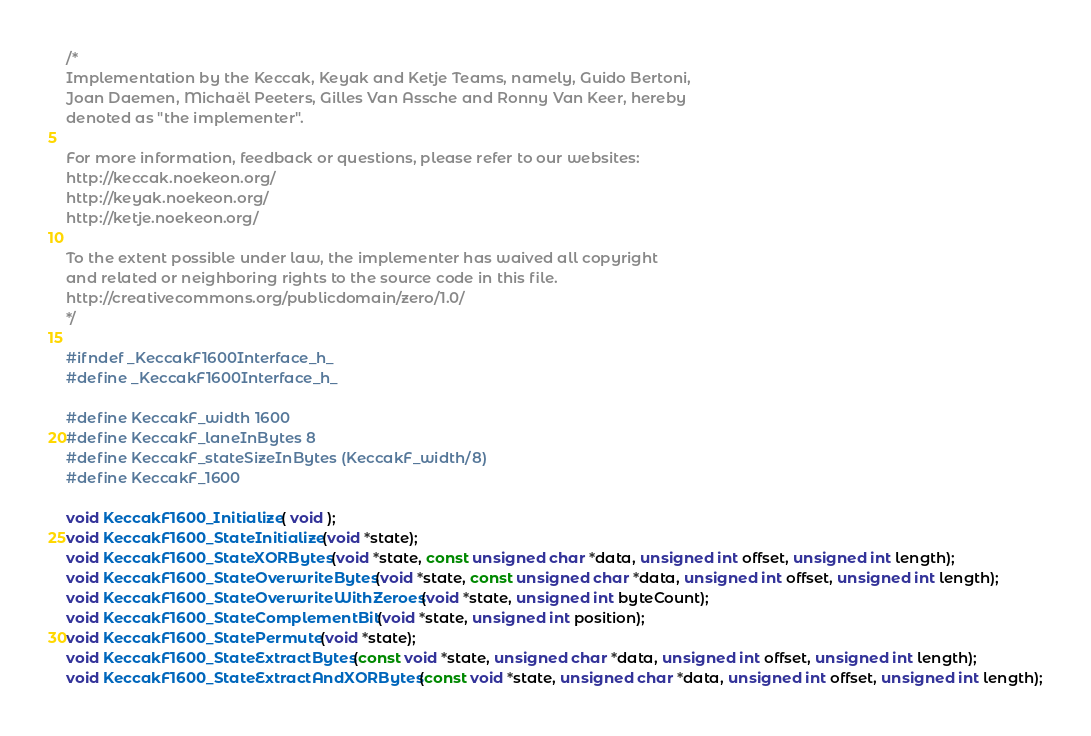Convert code to text. <code><loc_0><loc_0><loc_500><loc_500><_C_>/*
Implementation by the Keccak, Keyak and Ketje Teams, namely, Guido Bertoni,
Joan Daemen, Michaël Peeters, Gilles Van Assche and Ronny Van Keer, hereby
denoted as "the implementer".

For more information, feedback or questions, please refer to our websites:
http://keccak.noekeon.org/
http://keyak.noekeon.org/
http://ketje.noekeon.org/

To the extent possible under law, the implementer has waived all copyright
and related or neighboring rights to the source code in this file.
http://creativecommons.org/publicdomain/zero/1.0/
*/

#ifndef _KeccakF1600Interface_h_
#define _KeccakF1600Interface_h_

#define KeccakF_width 1600
#define KeccakF_laneInBytes 8
#define KeccakF_stateSizeInBytes (KeccakF_width/8)
#define KeccakF_1600

void KeccakF1600_Initialize( void );
void KeccakF1600_StateInitialize(void *state);
void KeccakF1600_StateXORBytes(void *state, const unsigned char *data, unsigned int offset, unsigned int length);
void KeccakF1600_StateOverwriteBytes(void *state, const unsigned char *data, unsigned int offset, unsigned int length);
void KeccakF1600_StateOverwriteWithZeroes(void *state, unsigned int byteCount);
void KeccakF1600_StateComplementBit(void *state, unsigned int position);
void KeccakF1600_StatePermute(void *state);
void KeccakF1600_StateExtractBytes(const void *state, unsigned char *data, unsigned int offset, unsigned int length);
void KeccakF1600_StateExtractAndXORBytes(const void *state, unsigned char *data, unsigned int offset, unsigned int length);</code> 